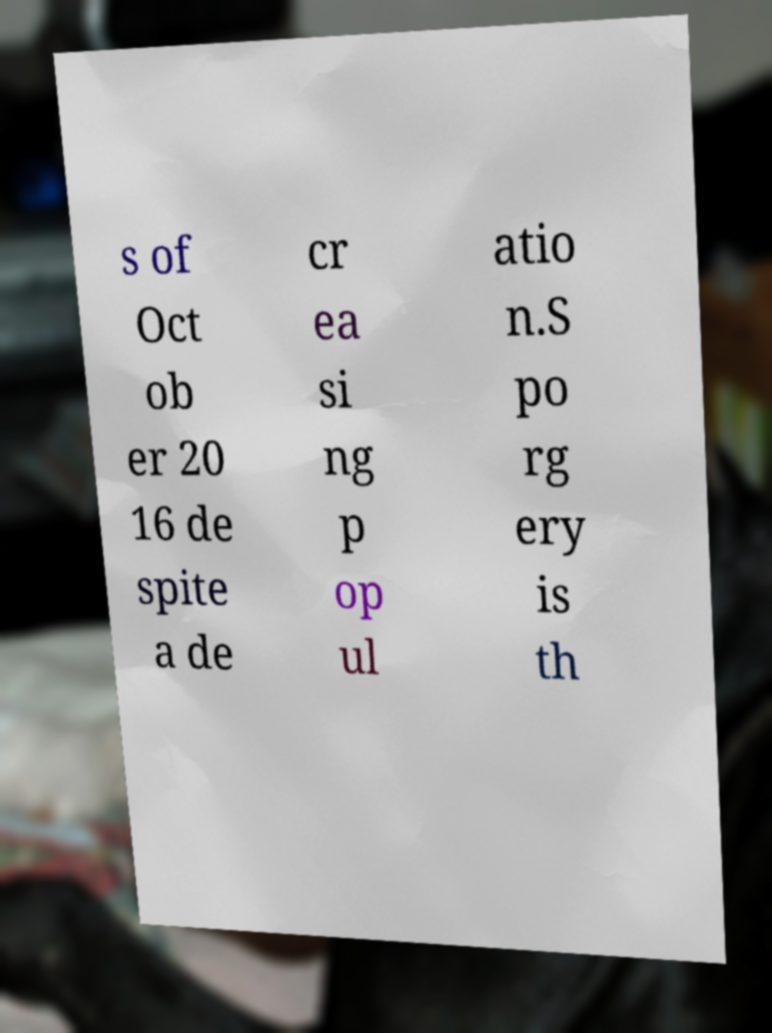Could you assist in decoding the text presented in this image and type it out clearly? s of Oct ob er 20 16 de spite a de cr ea si ng p op ul atio n.S po rg ery is th 